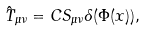<formula> <loc_0><loc_0><loc_500><loc_500>\hat { T } _ { \mu \nu } = C S _ { \mu \nu } \delta ( \Phi ( x ) ) ,</formula> 